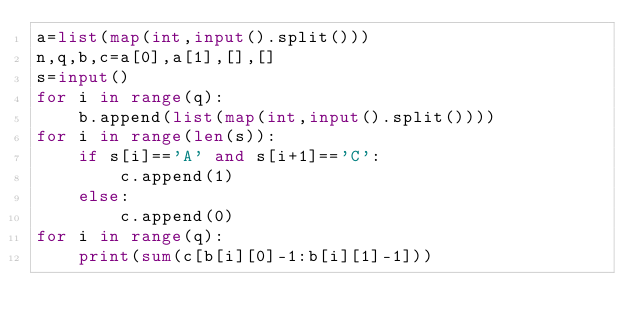<code> <loc_0><loc_0><loc_500><loc_500><_Python_>a=list(map(int,input().split()))
n,q,b,c=a[0],a[1],[],[]
s=input()
for i in range(q):
    b.append(list(map(int,input().split())))
for i in range(len(s)):
    if s[i]=='A' and s[i+1]=='C':
        c.append(1)
    else:
        c.append(0)
for i in range(q):
    print(sum(c[b[i][0]-1:b[i][1]-1]))</code> 